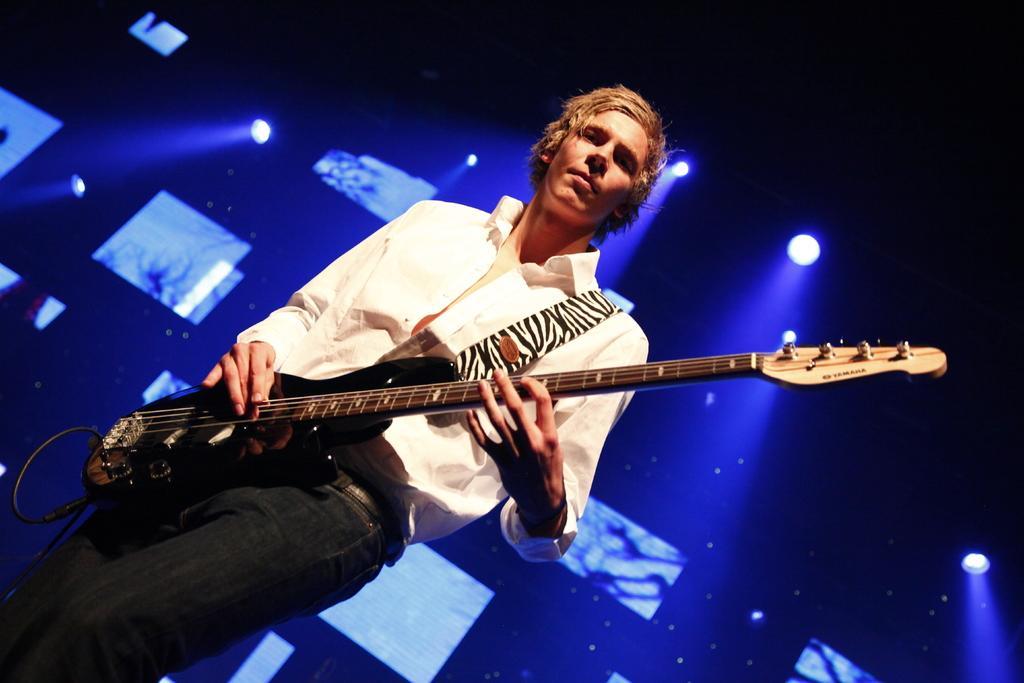Please provide a concise description of this image. In this image there is a man standing and playing a guitar , and the back ground there is screen and focus light. 